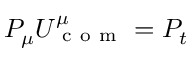Convert formula to latex. <formula><loc_0><loc_0><loc_500><loc_500>P _ { \mu } U _ { c o m } ^ { \mu } = P _ { t }</formula> 